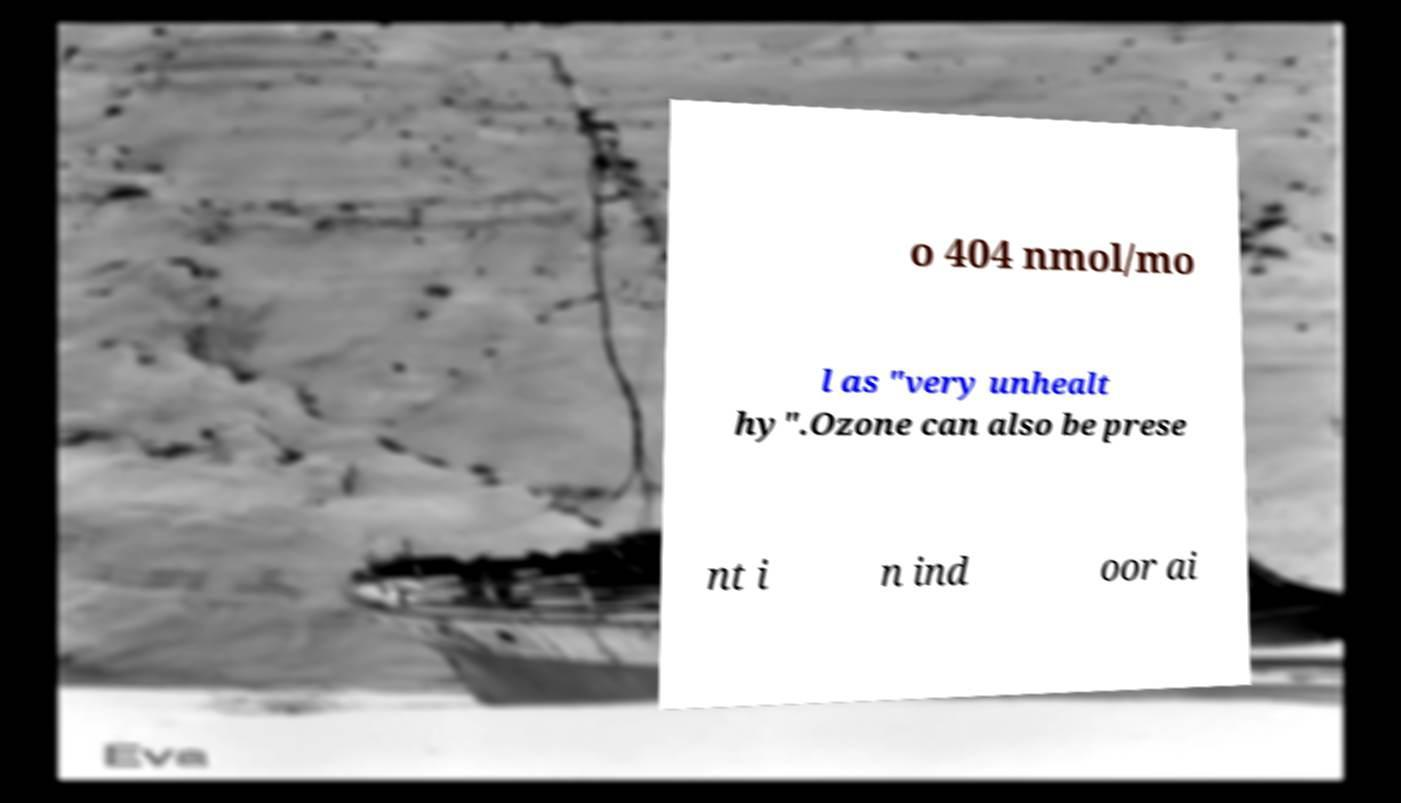Could you extract and type out the text from this image? o 404 nmol/mo l as "very unhealt hy".Ozone can also be prese nt i n ind oor ai 